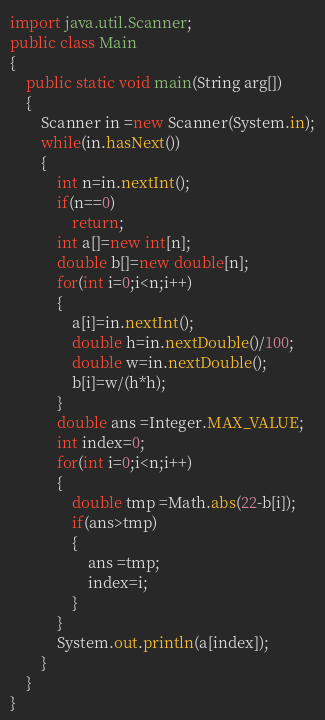Convert code to text. <code><loc_0><loc_0><loc_500><loc_500><_Java_>import java.util.Scanner;
public class Main
{	
	public static void main(String arg[])
	{
		Scanner in =new Scanner(System.in);
		while(in.hasNext())
		{
			int n=in.nextInt();
			if(n==0)
				return;
			int a[]=new int[n];
			double b[]=new double[n];
			for(int i=0;i<n;i++)
			{
				a[i]=in.nextInt();
				double h=in.nextDouble()/100;
				double w=in.nextDouble();
				b[i]=w/(h*h);
			}
			double ans =Integer.MAX_VALUE;
			int index=0;
			for(int i=0;i<n;i++)
			{
				double tmp =Math.abs(22-b[i]);
				if(ans>tmp)
				{
					ans =tmp;
					index=i;
				}
			}
			System.out.println(a[index]);
		}
	}
}</code> 